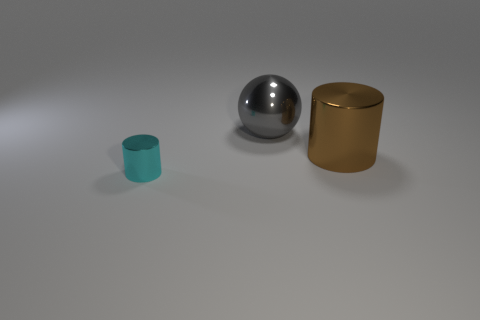Are there an equal number of cylinders in front of the big metal cylinder and big gray metal spheres left of the large gray sphere?
Keep it short and to the point. No. What is the color of the small metal cylinder in front of the metallic cylinder right of the metal cylinder that is on the left side of the gray shiny thing?
Your answer should be compact. Cyan. There is a thing that is on the right side of the large gray metallic ball; what is its size?
Ensure brevity in your answer.  Large. What is the shape of the brown shiny object that is the same size as the gray metal object?
Give a very brief answer. Cylinder. Do the cylinder on the right side of the tiny shiny cylinder and the object to the left of the gray shiny ball have the same material?
Your answer should be very brief. Yes. There is a thing behind the large metallic object to the right of the gray object; what is its material?
Your answer should be very brief. Metal. What is the size of the cylinder that is to the left of the big thing that is behind the cylinder right of the tiny cyan metal object?
Your answer should be very brief. Small. Is the brown cylinder the same size as the shiny sphere?
Give a very brief answer. Yes. There is a large object behind the large brown object; is it the same shape as the metallic object that is in front of the big cylinder?
Give a very brief answer. No. Are there any tiny things that are in front of the metal thing that is behind the brown shiny cylinder?
Keep it short and to the point. Yes. 